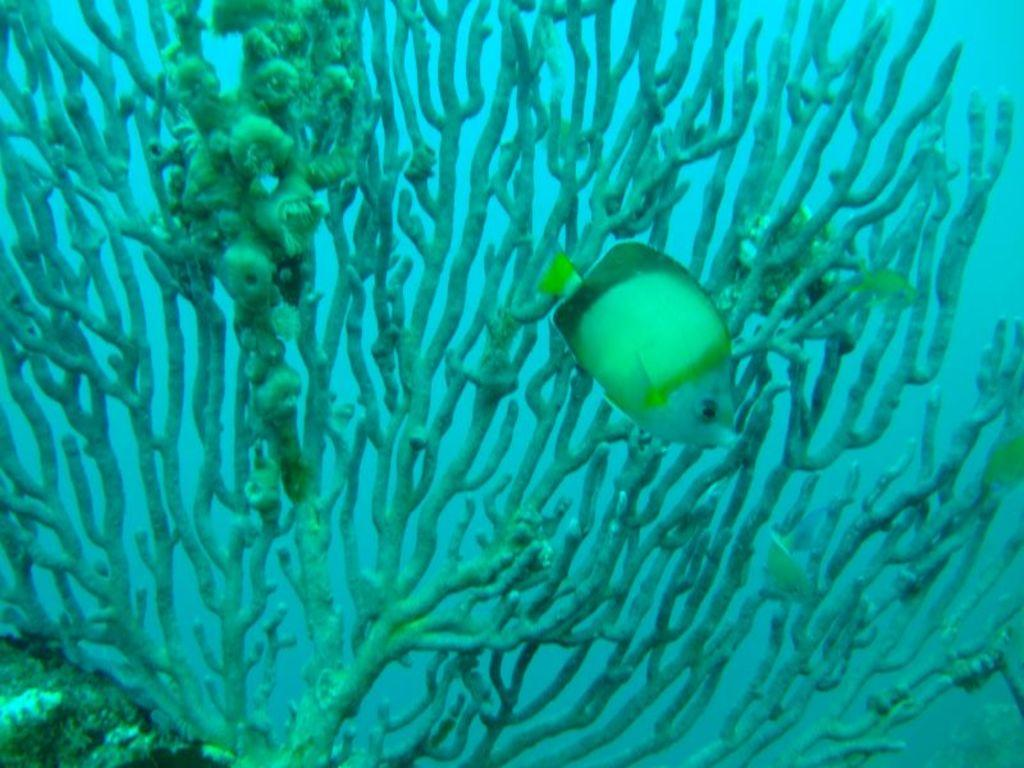What type of animal can be seen in the image? There is a fish in the image. What else is present in the image besides the fish? There are plants in the image. Can you describe the setting of the image? The image appears to be taken underwater. What type of harmony is being played by the guitar in the image? There is no guitar present in the image; it features a fish and plants underwater. 